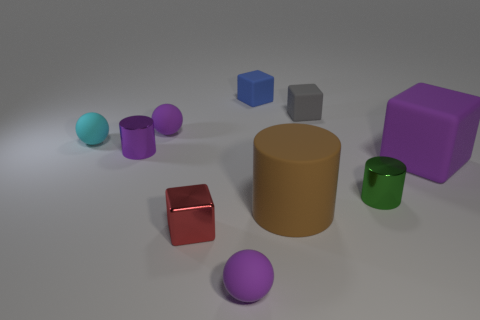Subtract all big purple matte blocks. How many blocks are left? 3 Subtract all purple cylinders. How many cylinders are left? 2 Subtract all blocks. How many objects are left? 6 Subtract 2 cylinders. How many cylinders are left? 1 Subtract all brown spheres. How many gray cubes are left? 1 Subtract all small blue metallic things. Subtract all big brown objects. How many objects are left? 9 Add 7 matte cylinders. How many matte cylinders are left? 8 Add 3 brown objects. How many brown objects exist? 4 Subtract 0 yellow balls. How many objects are left? 10 Subtract all green blocks. Subtract all red cylinders. How many blocks are left? 4 